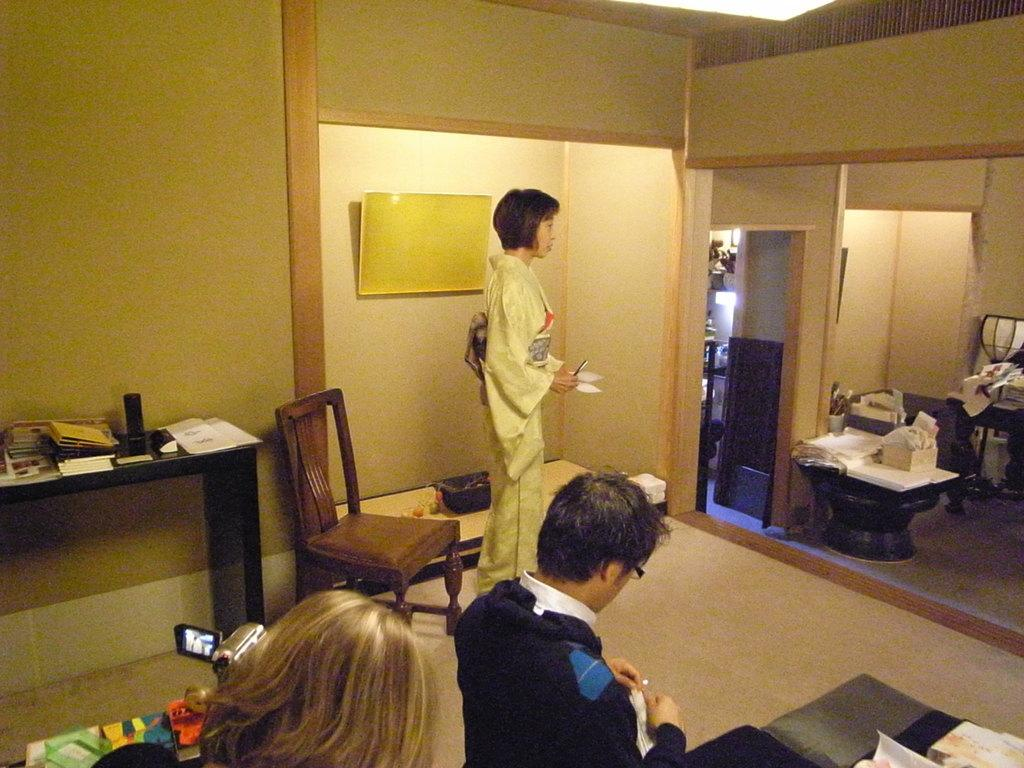How many people are present in the image? There is a man and a woman in the image. What object can be used for sitting in the image? There is a chair in the image. Can you describe another object in the image besides the people and chair? There appears to be a statue in the image. What type of clam is sitting on the chair in the image? There is no clam present in the image; it features a man and a woman, a chair, and a statue. 